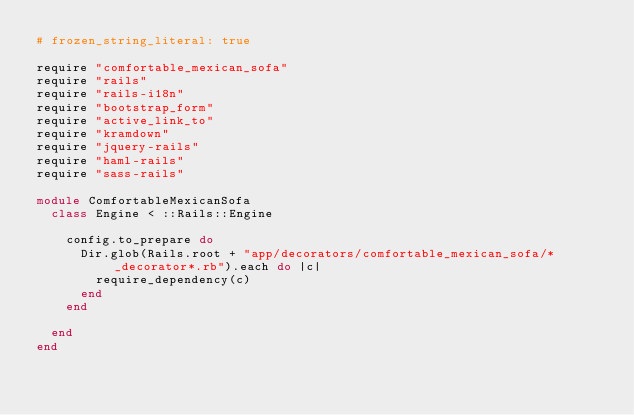<code> <loc_0><loc_0><loc_500><loc_500><_Ruby_># frozen_string_literal: true

require "comfortable_mexican_sofa"
require "rails"
require "rails-i18n"
require "bootstrap_form"
require "active_link_to"
require "kramdown"
require "jquery-rails"
require "haml-rails"
require "sass-rails"

module ComfortableMexicanSofa
  class Engine < ::Rails::Engine

    config.to_prepare do
      Dir.glob(Rails.root + "app/decorators/comfortable_mexican_sofa/*_decorator*.rb").each do |c|
        require_dependency(c)
      end
    end

  end
end
</code> 